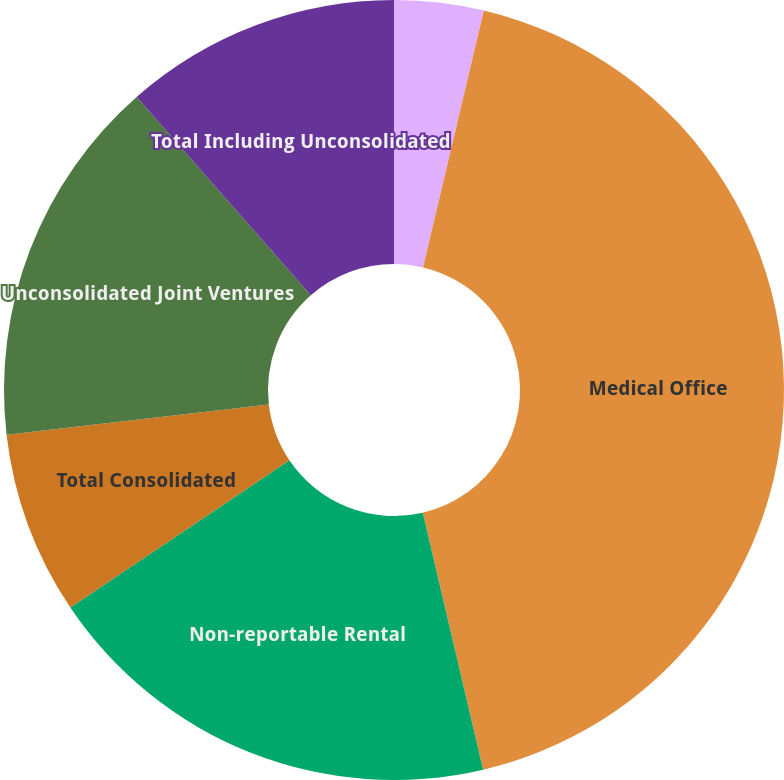Convert chart to OTSL. <chart><loc_0><loc_0><loc_500><loc_500><pie_chart><fcel>Industrial<fcel>Medical Office<fcel>Non-reportable Rental<fcel>Total Consolidated<fcel>Unconsolidated Joint Ventures<fcel>Total Including Unconsolidated<nl><fcel>3.7%<fcel>42.63%<fcel>19.25%<fcel>7.59%<fcel>15.36%<fcel>11.47%<nl></chart> 